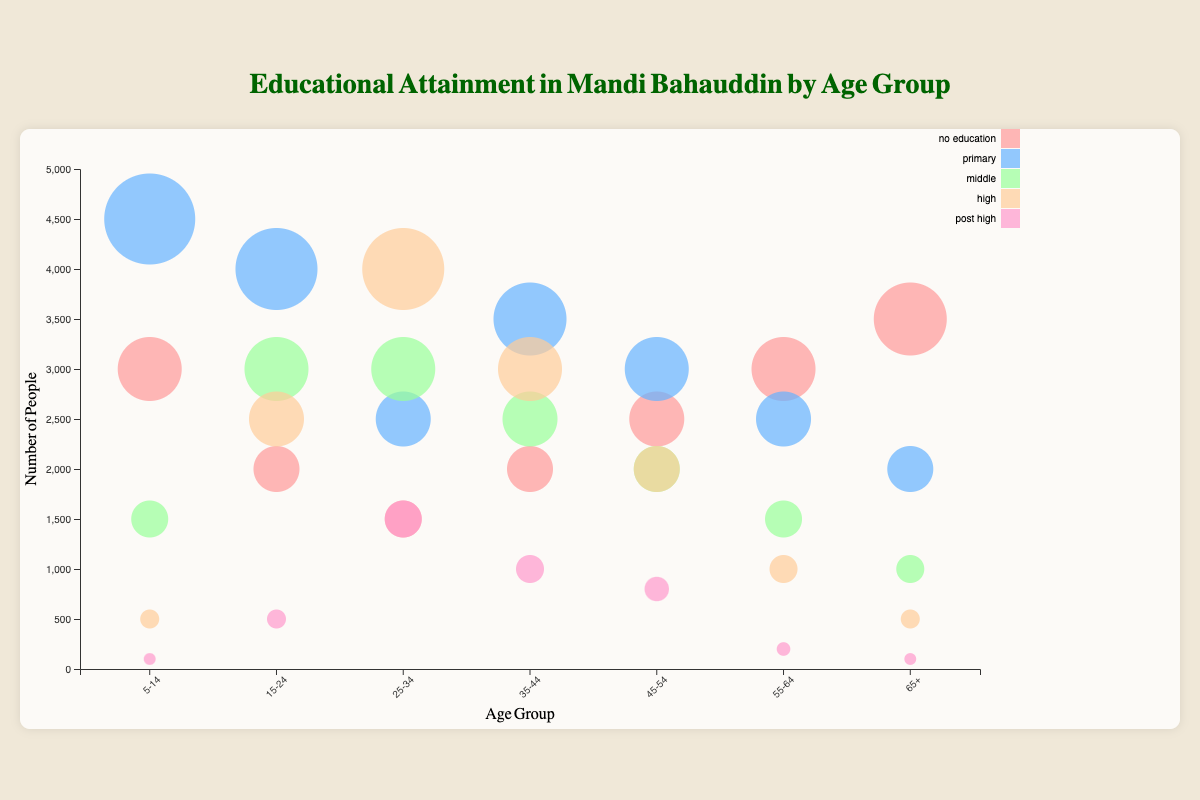What is the title of the chart? The title is usually displayed at the top of the chart. Here, it is "Educational Attainment in Mandi Bahauddin by Age Group".
Answer: Educational Attainment in Mandi Bahauddin by Age Group Which age group has the highest number of people with no education? By looking at the largest bubble labeled "no_education", it's clear the age group "65+" has the highest number, at 3500.
Answer: 65+ How many people in total have completed post-high education across all age groups? Add all the values in the "post_high" category: 100 (5-14) + 500 (15-24) + 1500 (25-34) + 1000 (35-44) + 800 (45-54) + 200 (55-64) + 100 (65+).
Answer: 4200 Compare the number of people with primary education in age groups 5-14 and 45-54. Which group has more and by how much? The number of people with primary education is 4500 in age group 5-14 and 3000 in age group 45-54.
Answer: Age group 5-14 has 1500 more What percentage of people aged 25-34 have completed high school education relative to the total number of people in the same age group? The number of people aged 25-34 with high education is 4000. The total in this age group is: 1500 (no)/2500 (primary)/3000 (middle)/4000 (high)/1500 (post_high) = 12500. The percentage is (4000/12500 * 100).
Answer: 32% Which age group has the smallest bubble for middle education? The smallest bubble indicating "middle" education is for the age group "65+", with 1000 people.
Answer: 65+ Looking at the tooltip information for the high education category, which age group has the second-highest number of people completing high school? By checking the bubbles, the second-highest for "high" education is age group 35-44 with 3000 people. The highest is 25-34 with 4000.
Answer: 35-44 In which age group does primary education surpass the middle education level the most? Subtract the middle education number from the primary education for each group, the largest difference occurs in 5-14 years: 4500 (primary) - 1500 (middle) = 3000.
Answer: 5-14 What is the range of people having no education across all age groups? The range is calculated as the difference between the maximum and minimum values in the "no_education" category, which are 3500 (65+) and 1500 (25-34).
Answer: 2000 